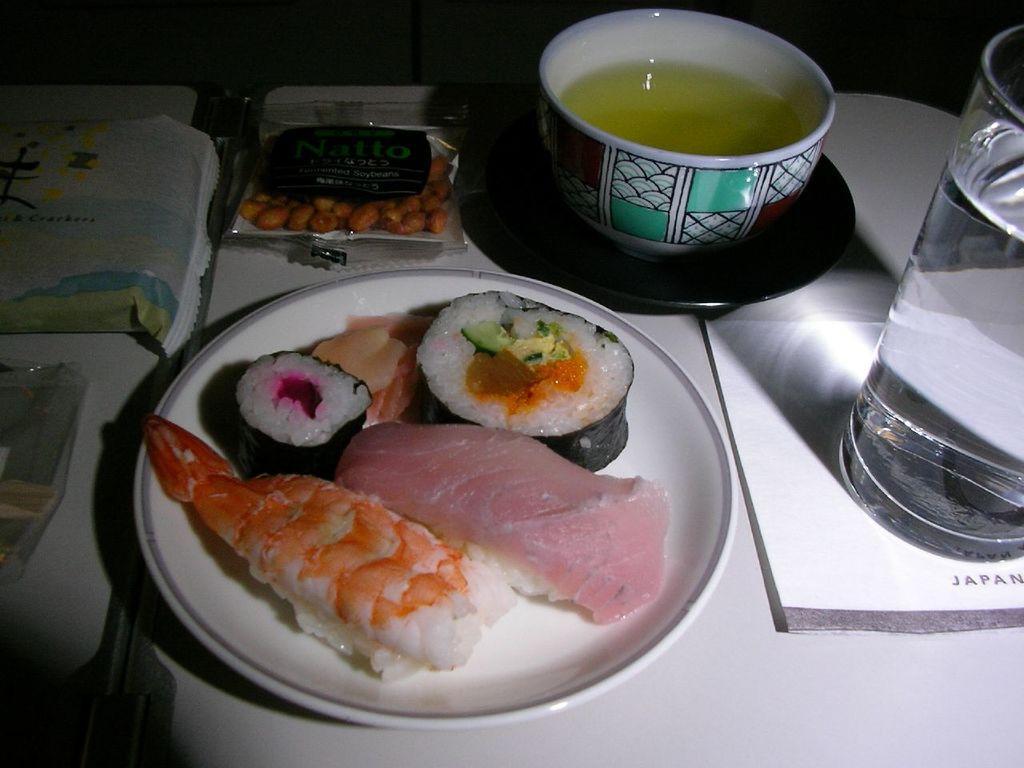In one or two sentences, can you explain what this image depicts? In this picture there is a plate which contains food in it, which is placed in the center of the image, there is a ground nuts packet and cup and saucer at the top side of the image. 